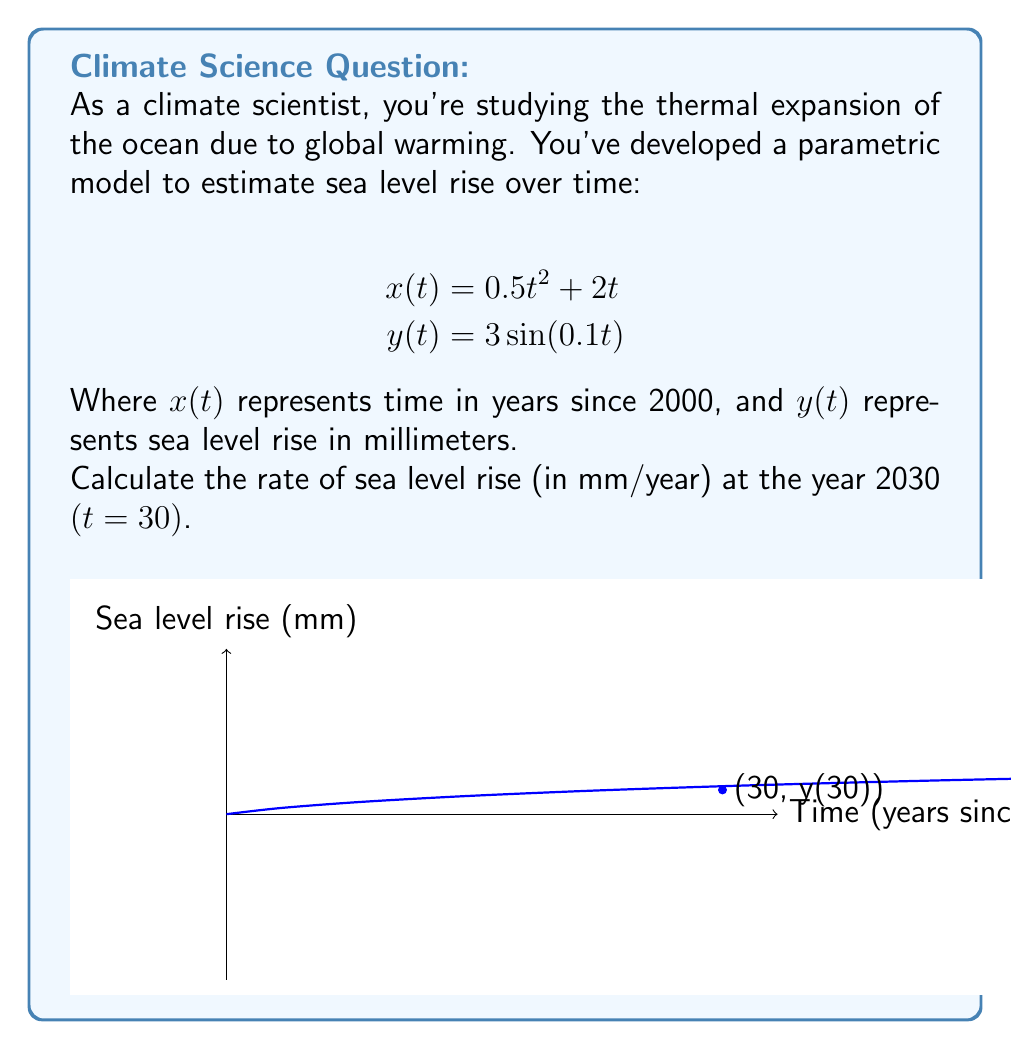Provide a solution to this math problem. To solve this problem, we need to follow these steps:

1) First, we need to find the derivative of y with respect to x at t = 30. This will give us the rate of change of sea level rise with respect to time.

2) To do this, we'll use the chain rule:

   $$\frac{dy}{dx} = \frac{dy/dt}{dx/dt}$$

3) Let's calculate $dx/dt$ and $dy/dt$:

   $$\frac{dx}{dt} = \frac{d}{dt}(0.5t^2 + 2t) = t + 2$$
   
   $$\frac{dy}{dt} = \frac{d}{dt}(3\sin(0.1t)) = 0.3\cos(0.1t)$$

4) Now, we can substitute these into our equation:

   $$\frac{dy}{dx} = \frac{0.3\cos(0.1t)}{t + 2}$$

5) We want to evaluate this at t = 30:

   $$\frac{dy}{dx}\bigg|_{t=30} = \frac{0.3\cos(0.1 * 30)}{30 + 2} = \frac{0.3\cos(3)}{32}$$

6) Let's calculate this:
   
   $$\frac{0.3 * (-0.9899924966)}{32} \approx -0.00928$$

7) The negative sign indicates that sea level is actually decreasing at this point in the model, which could represent a temporary fluctuation in the overall rising trend.
Answer: $-0.00928$ mm/year 